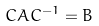<formula> <loc_0><loc_0><loc_500><loc_500>C A C ^ { - 1 } = B</formula> 